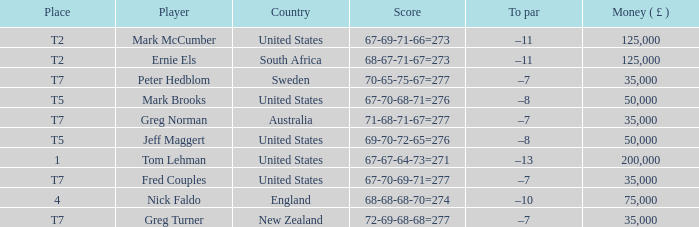What is To par, when Player is "Greg Turner"? –7. 